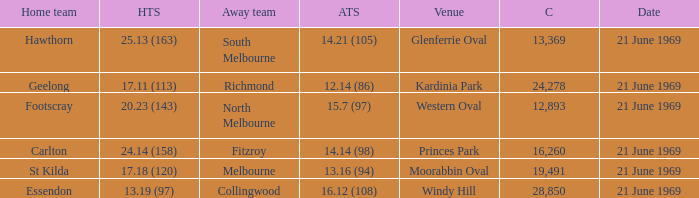What is Essendon's home team that has an away crowd size larger than 19,491? Collingwood. 